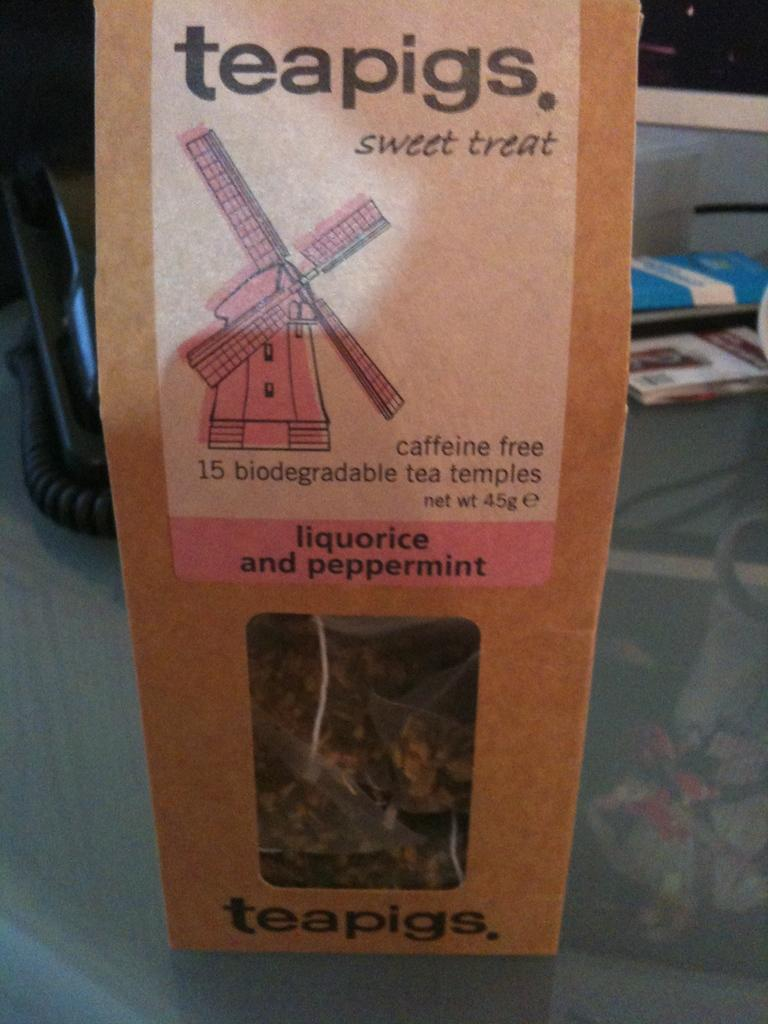<image>
Write a terse but informative summary of the picture. The nice treat is flavoured with liquorice and peppermint. 